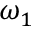<formula> <loc_0><loc_0><loc_500><loc_500>\omega _ { 1 }</formula> 